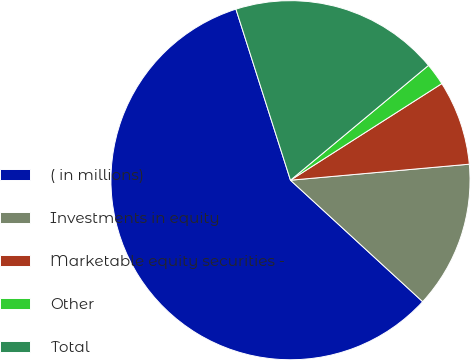Convert chart to OTSL. <chart><loc_0><loc_0><loc_500><loc_500><pie_chart><fcel>( in millions)<fcel>Investments in equity<fcel>Marketable equity securities -<fcel>Other<fcel>Total<nl><fcel>58.26%<fcel>13.25%<fcel>7.62%<fcel>2.0%<fcel>18.87%<nl></chart> 